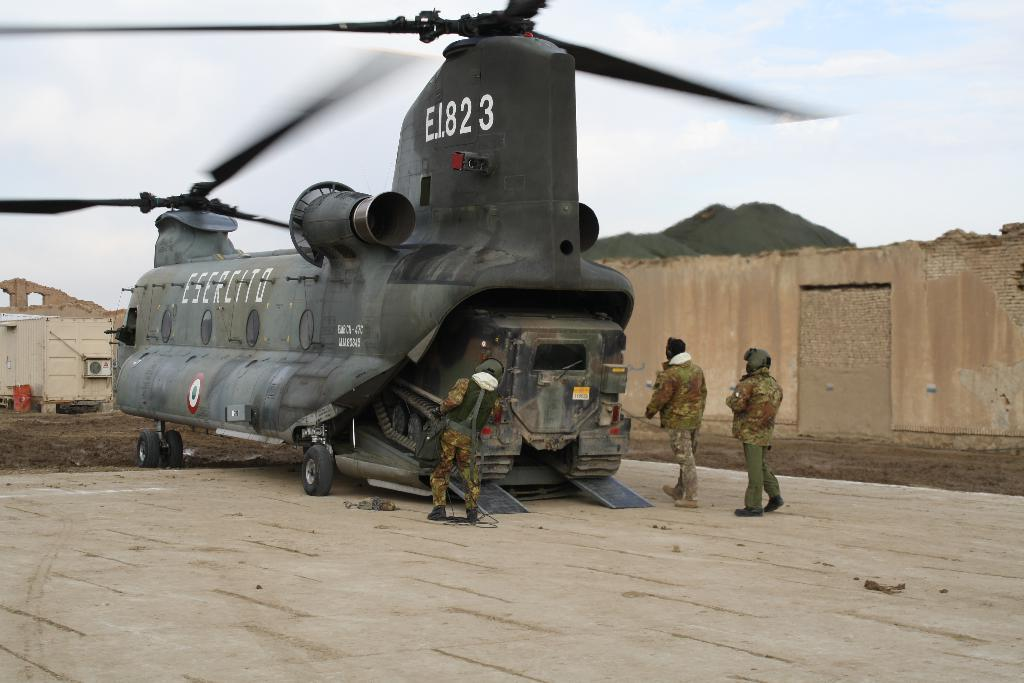What is the main subject of the image? The main subject of the image is an aircraft on the ground. Are there any people present in the image? Yes, there are three persons standing near the aircraft. What else can be seen in the image besides the aircraft and people? There is a container in the image. What can be seen in the background of the image? There is a wall and the sky visible in the background of the image. What type of knowledge is being shared on the stage in the image? There is no stage present in the image, so no knowledge can be shared on a stage. 